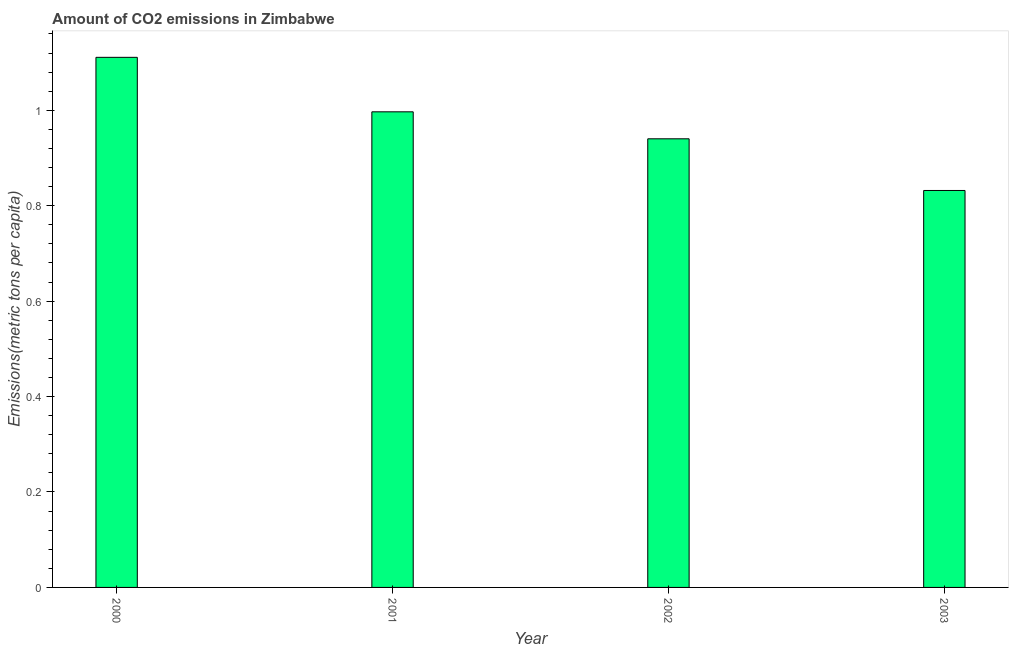Does the graph contain any zero values?
Give a very brief answer. No. Does the graph contain grids?
Ensure brevity in your answer.  No. What is the title of the graph?
Your answer should be compact. Amount of CO2 emissions in Zimbabwe. What is the label or title of the X-axis?
Make the answer very short. Year. What is the label or title of the Y-axis?
Your answer should be compact. Emissions(metric tons per capita). What is the amount of co2 emissions in 2001?
Provide a succinct answer. 1. Across all years, what is the maximum amount of co2 emissions?
Provide a succinct answer. 1.11. Across all years, what is the minimum amount of co2 emissions?
Ensure brevity in your answer.  0.83. What is the sum of the amount of co2 emissions?
Make the answer very short. 3.88. What is the difference between the amount of co2 emissions in 2002 and 2003?
Your response must be concise. 0.11. What is the median amount of co2 emissions?
Your answer should be very brief. 0.97. In how many years, is the amount of co2 emissions greater than 0.28 metric tons per capita?
Your response must be concise. 4. Do a majority of the years between 2002 and 2001 (inclusive) have amount of co2 emissions greater than 0.04 metric tons per capita?
Your response must be concise. No. What is the ratio of the amount of co2 emissions in 2000 to that in 2002?
Provide a succinct answer. 1.18. Is the amount of co2 emissions in 2000 less than that in 2003?
Your answer should be very brief. No. What is the difference between the highest and the second highest amount of co2 emissions?
Provide a short and direct response. 0.11. Is the sum of the amount of co2 emissions in 2002 and 2003 greater than the maximum amount of co2 emissions across all years?
Your answer should be very brief. Yes. What is the difference between the highest and the lowest amount of co2 emissions?
Give a very brief answer. 0.28. In how many years, is the amount of co2 emissions greater than the average amount of co2 emissions taken over all years?
Your response must be concise. 2. How many bars are there?
Ensure brevity in your answer.  4. Are all the bars in the graph horizontal?
Offer a very short reply. No. How many years are there in the graph?
Keep it short and to the point. 4. What is the difference between two consecutive major ticks on the Y-axis?
Make the answer very short. 0.2. Are the values on the major ticks of Y-axis written in scientific E-notation?
Your answer should be very brief. No. What is the Emissions(metric tons per capita) in 2000?
Provide a succinct answer. 1.11. What is the Emissions(metric tons per capita) in 2001?
Your answer should be compact. 1. What is the Emissions(metric tons per capita) of 2002?
Ensure brevity in your answer.  0.94. What is the Emissions(metric tons per capita) of 2003?
Make the answer very short. 0.83. What is the difference between the Emissions(metric tons per capita) in 2000 and 2001?
Offer a terse response. 0.11. What is the difference between the Emissions(metric tons per capita) in 2000 and 2002?
Your answer should be very brief. 0.17. What is the difference between the Emissions(metric tons per capita) in 2000 and 2003?
Your response must be concise. 0.28. What is the difference between the Emissions(metric tons per capita) in 2001 and 2002?
Ensure brevity in your answer.  0.06. What is the difference between the Emissions(metric tons per capita) in 2001 and 2003?
Give a very brief answer. 0.16. What is the difference between the Emissions(metric tons per capita) in 2002 and 2003?
Your answer should be very brief. 0.11. What is the ratio of the Emissions(metric tons per capita) in 2000 to that in 2001?
Offer a terse response. 1.11. What is the ratio of the Emissions(metric tons per capita) in 2000 to that in 2002?
Ensure brevity in your answer.  1.18. What is the ratio of the Emissions(metric tons per capita) in 2000 to that in 2003?
Your answer should be compact. 1.33. What is the ratio of the Emissions(metric tons per capita) in 2001 to that in 2002?
Keep it short and to the point. 1.06. What is the ratio of the Emissions(metric tons per capita) in 2001 to that in 2003?
Your answer should be very brief. 1.2. What is the ratio of the Emissions(metric tons per capita) in 2002 to that in 2003?
Your response must be concise. 1.13. 